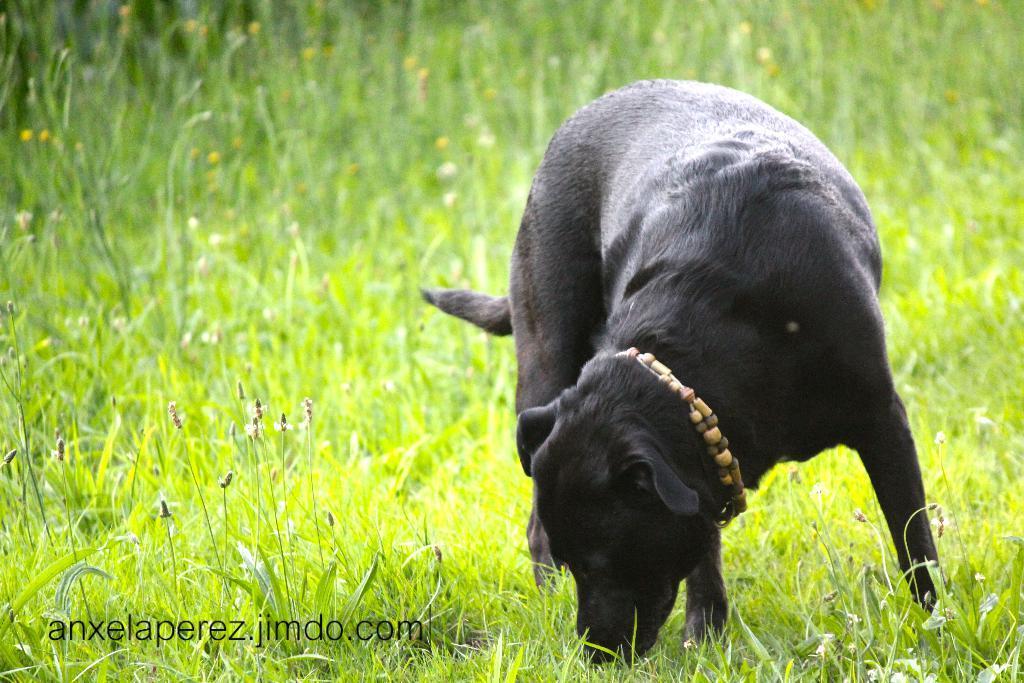Can you describe this image briefly? In this image we can see a dog standing on the grass and we can also see some at the bottom. 